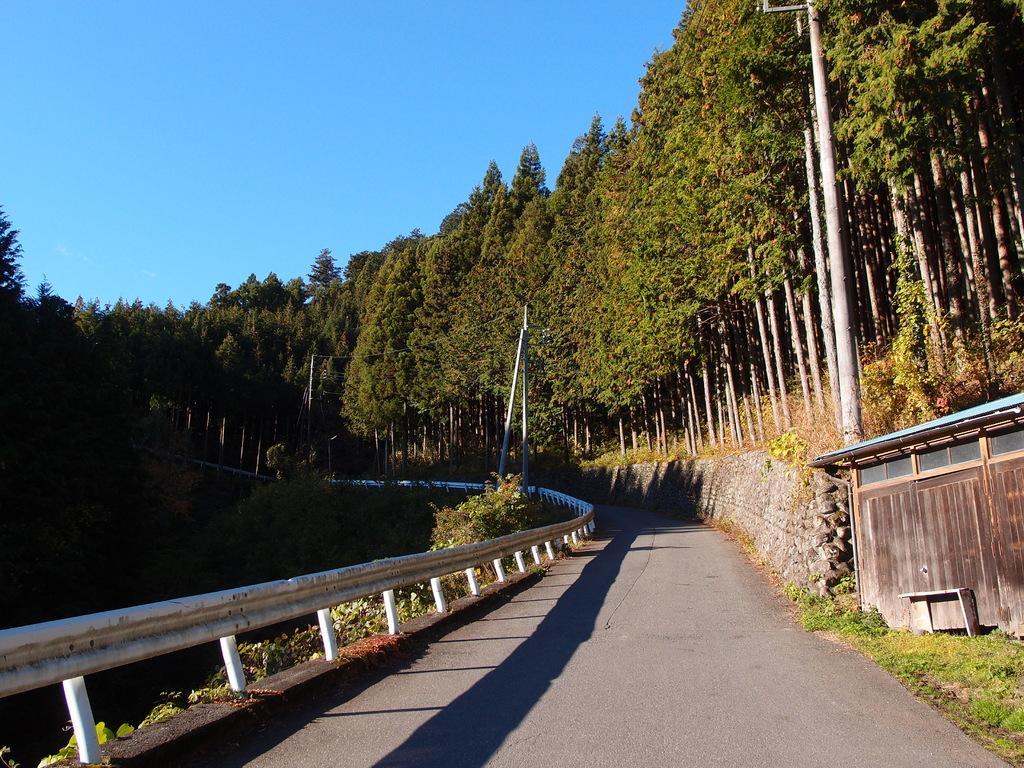In one or two sentences, can you explain what this image depicts? In this image we can see trees, road, fencing, plants, hut and sky. 